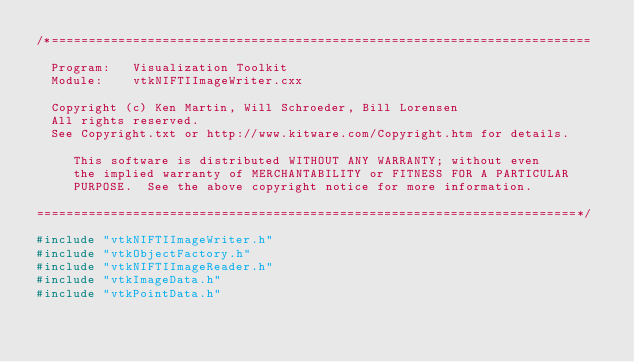Convert code to text. <code><loc_0><loc_0><loc_500><loc_500><_C++_>/*=========================================================================

  Program:   Visualization Toolkit
  Module:    vtkNIFTIImageWriter.cxx

  Copyright (c) Ken Martin, Will Schroeder, Bill Lorensen
  All rights reserved.
  See Copyright.txt or http://www.kitware.com/Copyright.htm for details.

     This software is distributed WITHOUT ANY WARRANTY; without even
     the implied warranty of MERCHANTABILITY or FITNESS FOR A PARTICULAR
     PURPOSE.  See the above copyright notice for more information.

=========================================================================*/

#include "vtkNIFTIImageWriter.h"
#include "vtkObjectFactory.h"
#include "vtkNIFTIImageReader.h"
#include "vtkImageData.h"
#include "vtkPointData.h"</code> 